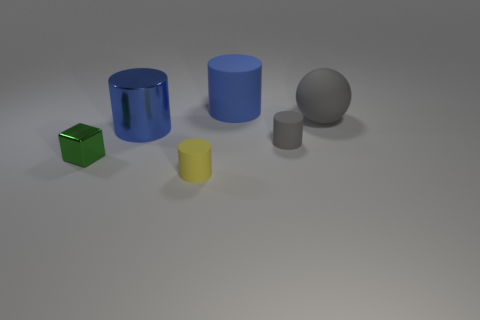Subtract all gray spheres. How many blue cylinders are left? 2 Add 1 gray spheres. How many objects exist? 7 Subtract all gray cylinders. How many cylinders are left? 3 Subtract all matte cylinders. How many cylinders are left? 1 Subtract 2 cylinders. How many cylinders are left? 2 Subtract all balls. How many objects are left? 5 Subtract all green cylinders. Subtract all gray spheres. How many cylinders are left? 4 Subtract all big matte objects. Subtract all rubber cylinders. How many objects are left? 1 Add 1 blue matte cylinders. How many blue matte cylinders are left? 2 Add 4 small things. How many small things exist? 7 